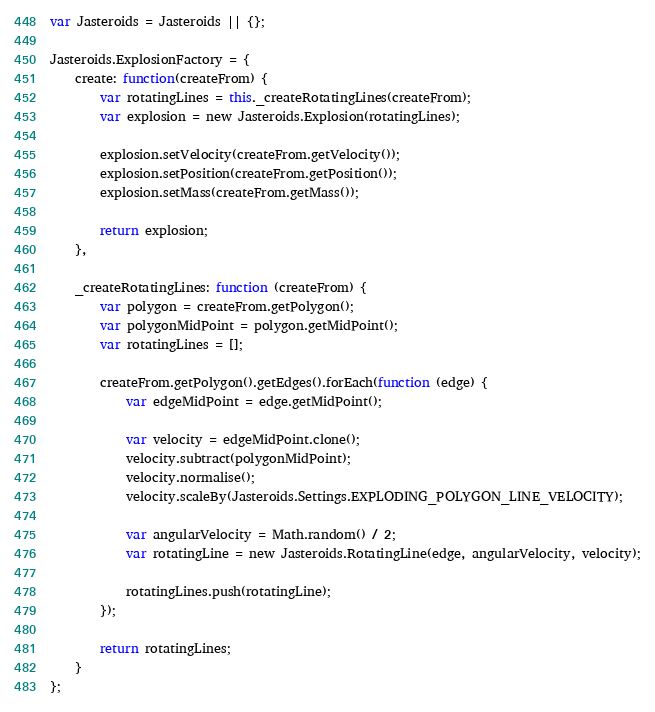<code> <loc_0><loc_0><loc_500><loc_500><_JavaScript_>var Jasteroids = Jasteroids || {};

Jasteroids.ExplosionFactory = {
    create: function(createFrom) {
        var rotatingLines = this._createRotatingLines(createFrom);
        var explosion = new Jasteroids.Explosion(rotatingLines);

        explosion.setVelocity(createFrom.getVelocity());
        explosion.setPosition(createFrom.getPosition());
        explosion.setMass(createFrom.getMass());

        return explosion;
    },

    _createRotatingLines: function (createFrom) {
        var polygon = createFrom.getPolygon();
        var polygonMidPoint = polygon.getMidPoint();
        var rotatingLines = [];

        createFrom.getPolygon().getEdges().forEach(function (edge) {
            var edgeMidPoint = edge.getMidPoint();

            var velocity = edgeMidPoint.clone();
            velocity.subtract(polygonMidPoint);
            velocity.normalise();
            velocity.scaleBy(Jasteroids.Settings.EXPLODING_POLYGON_LINE_VELOCITY);

            var angularVelocity = Math.random() / 2;
            var rotatingLine = new Jasteroids.RotatingLine(edge, angularVelocity, velocity);

            rotatingLines.push(rotatingLine);
        });

        return rotatingLines;
    }
};
</code> 